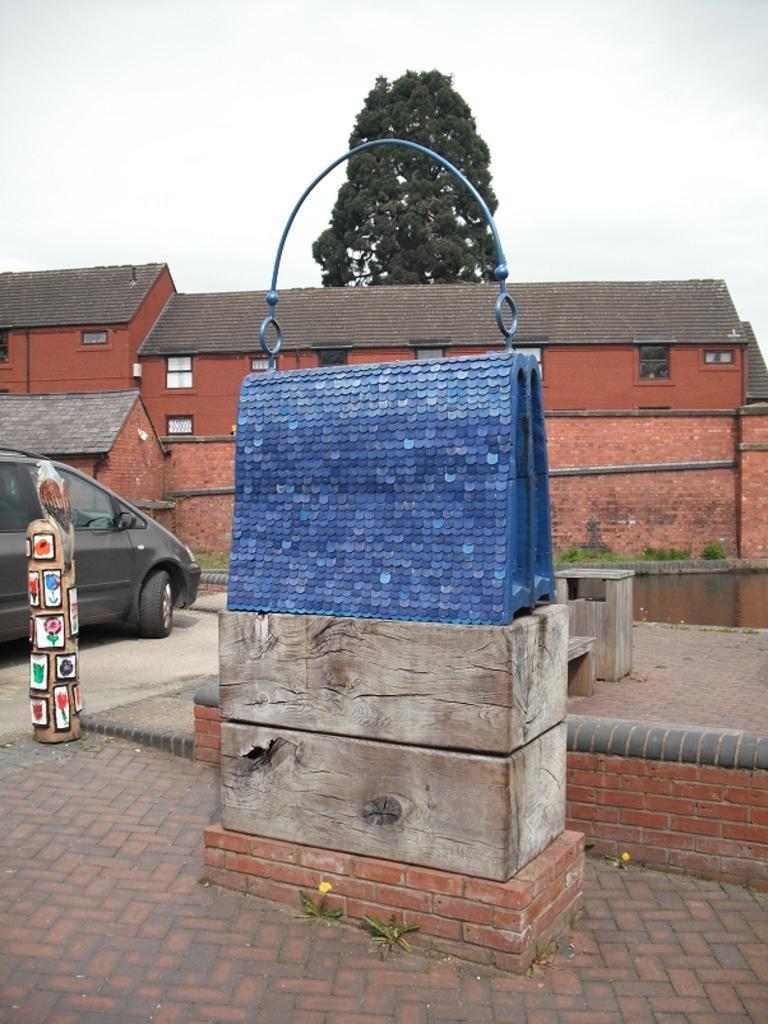Could you give a brief overview of what you see in this image? In this picture there is an object which is in blue color is placed on a wooden object and there is a car,building and some other objects in the left corner and there is a tree in the background. 